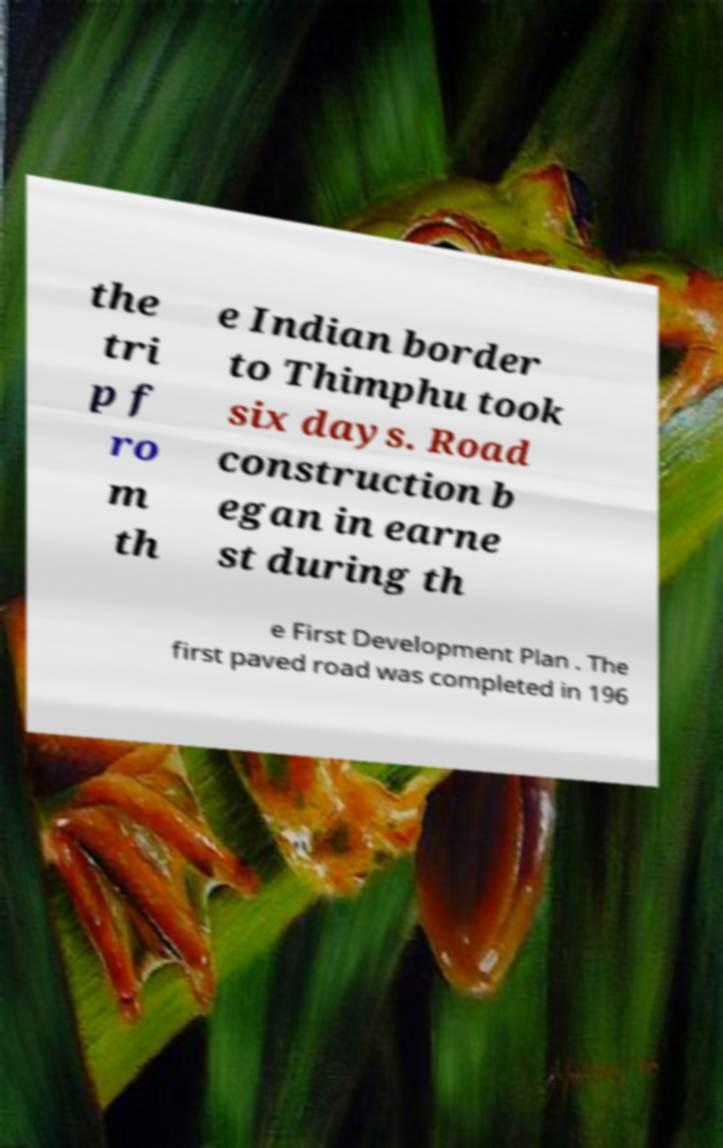Can you read and provide the text displayed in the image?This photo seems to have some interesting text. Can you extract and type it out for me? the tri p f ro m th e Indian border to Thimphu took six days. Road construction b egan in earne st during th e First Development Plan . The first paved road was completed in 196 